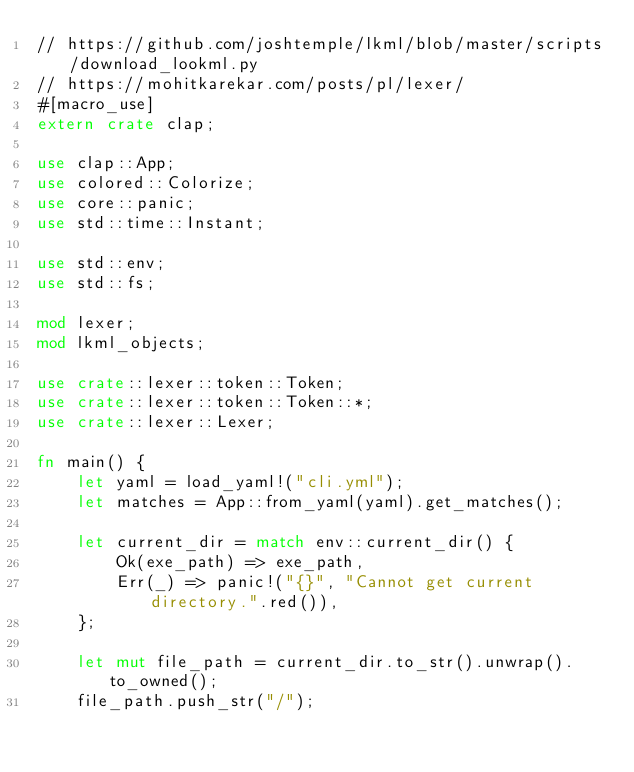<code> <loc_0><loc_0><loc_500><loc_500><_Rust_>// https://github.com/joshtemple/lkml/blob/master/scripts/download_lookml.py
// https://mohitkarekar.com/posts/pl/lexer/
#[macro_use]
extern crate clap;

use clap::App;
use colored::Colorize;
use core::panic;
use std::time::Instant;

use std::env;
use std::fs;

mod lexer;
mod lkml_objects;

use crate::lexer::token::Token;
use crate::lexer::token::Token::*;
use crate::lexer::Lexer;

fn main() {
    let yaml = load_yaml!("cli.yml");
    let matches = App::from_yaml(yaml).get_matches();

    let current_dir = match env::current_dir() {
        Ok(exe_path) => exe_path,
        Err(_) => panic!("{}", "Cannot get current directory.".red()),
    };

    let mut file_path = current_dir.to_str().unwrap().to_owned();
    file_path.push_str("/");</code> 